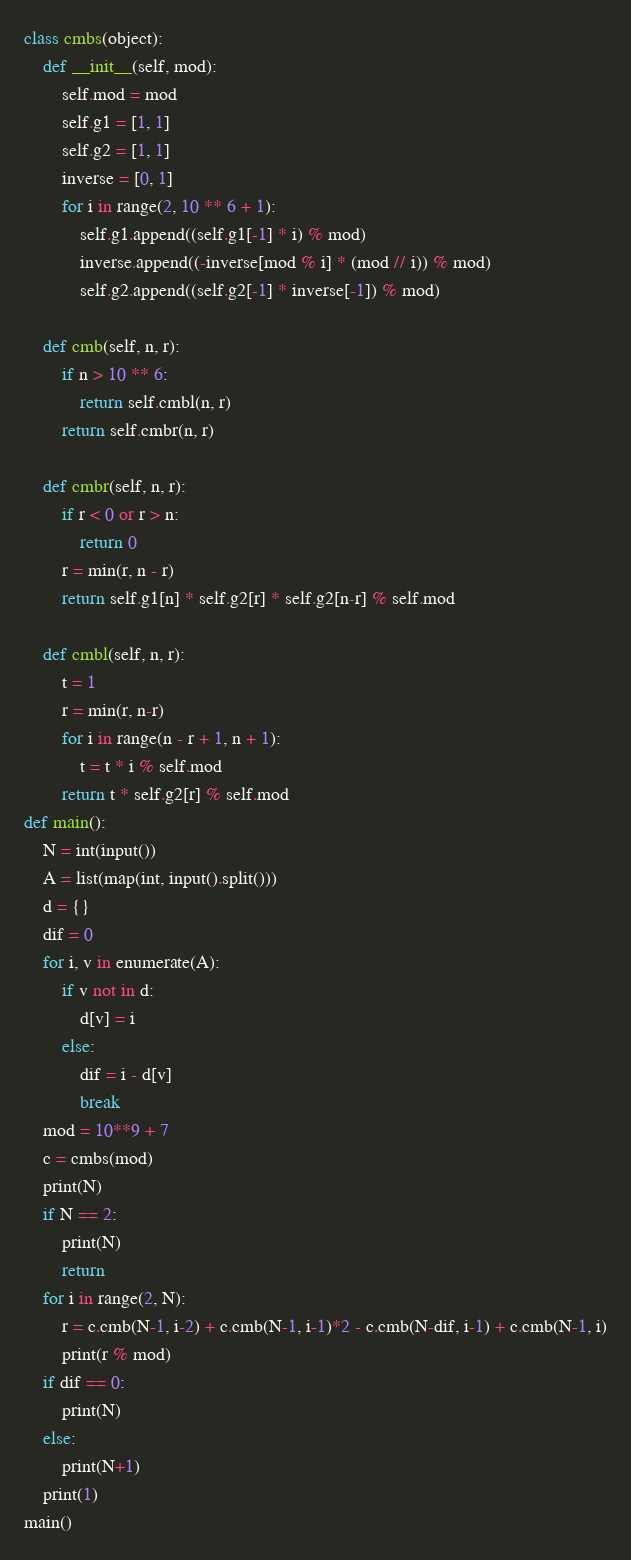<code> <loc_0><loc_0><loc_500><loc_500><_Python_>class cmbs(object):
    def __init__(self, mod):
        self.mod = mod
        self.g1 = [1, 1]
        self.g2 = [1, 1]
        inverse = [0, 1]
        for i in range(2, 10 ** 6 + 1):
            self.g1.append((self.g1[-1] * i) % mod)
            inverse.append((-inverse[mod % i] * (mod // i)) % mod)
            self.g2.append((self.g2[-1] * inverse[-1]) % mod)

    def cmb(self, n, r):
        if n > 10 ** 6:
            return self.cmbl(n, r)
        return self.cmbr(n, r)

    def cmbr(self, n, r):
        if r < 0 or r > n:
            return 0
        r = min(r, n - r)
        return self.g1[n] * self.g2[r] * self.g2[n-r] % self.mod

    def cmbl(self, n, r):
        t = 1
        r = min(r, n-r)
        for i in range(n - r + 1, n + 1):
            t = t * i % self.mod
        return t * self.g2[r] % self.mod
def main():
    N = int(input())
    A = list(map(int, input().split()))
    d = {}
    dif = 0
    for i, v in enumerate(A):
        if v not in d:
            d[v] = i
        else:
            dif = i - d[v]
            break
    mod = 10**9 + 7
    c = cmbs(mod)
    print(N)
    if N == 2:
        print(N)
        return
    for i in range(2, N):
        r = c.cmb(N-1, i-2) + c.cmb(N-1, i-1)*2 - c.cmb(N-dif, i-1) + c.cmb(N-1, i)
        print(r % mod)
    if dif == 0:
        print(N)
    else:
        print(N+1)
    print(1)
main()
</code> 